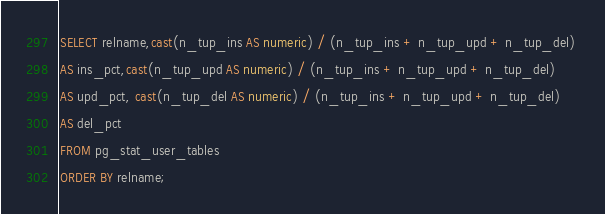<code> <loc_0><loc_0><loc_500><loc_500><_SQL_>SELECT relname,cast(n_tup_ins AS numeric) / (n_tup_ins + n_tup_upd + n_tup_del) 
AS ins_pct,cast(n_tup_upd AS numeric) / (n_tup_ins + n_tup_upd + n_tup_del) 
AS upd_pct, cast(n_tup_del AS numeric) / (n_tup_ins + n_tup_upd + n_tup_del) 
AS del_pct 
FROM pg_stat_user_tables
ORDER BY relname; 
</code> 